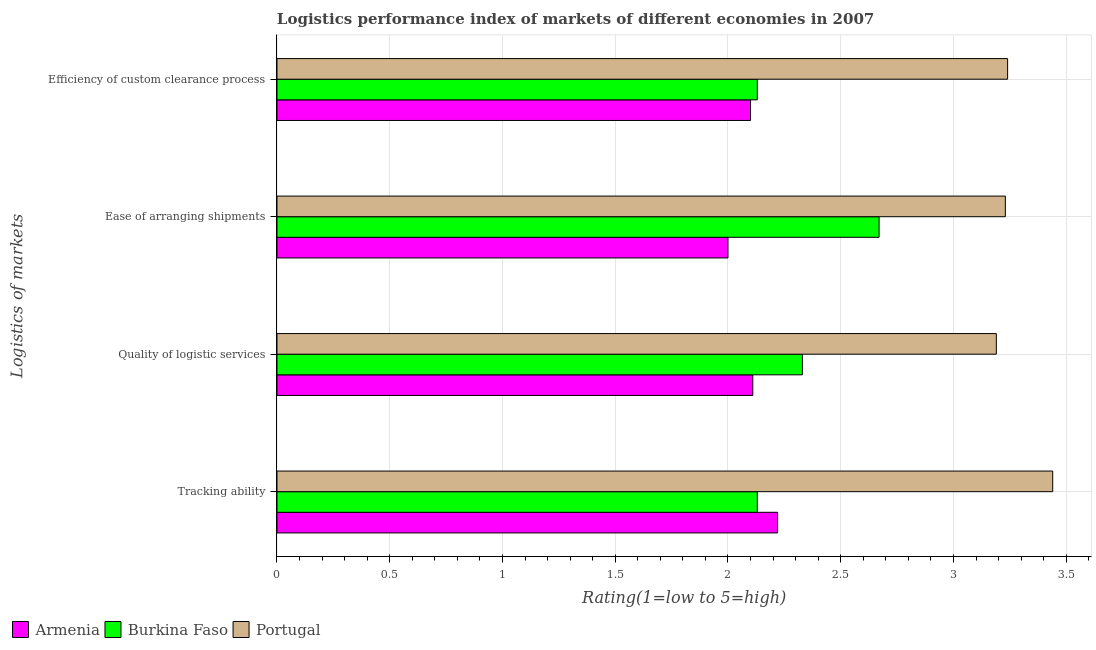Are the number of bars per tick equal to the number of legend labels?
Give a very brief answer. Yes. What is the label of the 4th group of bars from the top?
Keep it short and to the point. Tracking ability. What is the lpi rating of quality of logistic services in Burkina Faso?
Provide a succinct answer. 2.33. Across all countries, what is the maximum lpi rating of tracking ability?
Keep it short and to the point. 3.44. Across all countries, what is the minimum lpi rating of efficiency of custom clearance process?
Offer a very short reply. 2.1. In which country was the lpi rating of tracking ability minimum?
Make the answer very short. Burkina Faso. What is the difference between the lpi rating of efficiency of custom clearance process in Portugal and that in Armenia?
Make the answer very short. 1.14. What is the difference between the lpi rating of efficiency of custom clearance process in Burkina Faso and the lpi rating of tracking ability in Armenia?
Your answer should be compact. -0.09. What is the average lpi rating of efficiency of custom clearance process per country?
Keep it short and to the point. 2.49. What is the difference between the lpi rating of ease of arranging shipments and lpi rating of efficiency of custom clearance process in Armenia?
Your answer should be very brief. -0.1. In how many countries, is the lpi rating of tracking ability greater than 2.6 ?
Provide a short and direct response. 1. What is the ratio of the lpi rating of efficiency of custom clearance process in Armenia to that in Burkina Faso?
Provide a succinct answer. 0.99. Is the difference between the lpi rating of efficiency of custom clearance process in Armenia and Portugal greater than the difference between the lpi rating of quality of logistic services in Armenia and Portugal?
Give a very brief answer. No. What is the difference between the highest and the second highest lpi rating of ease of arranging shipments?
Ensure brevity in your answer.  0.56. What is the difference between the highest and the lowest lpi rating of ease of arranging shipments?
Your answer should be very brief. 1.23. Is the sum of the lpi rating of ease of arranging shipments in Portugal and Armenia greater than the maximum lpi rating of tracking ability across all countries?
Keep it short and to the point. Yes. Is it the case that in every country, the sum of the lpi rating of quality of logistic services and lpi rating of efficiency of custom clearance process is greater than the sum of lpi rating of ease of arranging shipments and lpi rating of tracking ability?
Keep it short and to the point. No. What does the 2nd bar from the bottom in Efficiency of custom clearance process represents?
Provide a short and direct response. Burkina Faso. Is it the case that in every country, the sum of the lpi rating of tracking ability and lpi rating of quality of logistic services is greater than the lpi rating of ease of arranging shipments?
Give a very brief answer. Yes. How many bars are there?
Ensure brevity in your answer.  12. How many countries are there in the graph?
Keep it short and to the point. 3. What is the difference between two consecutive major ticks on the X-axis?
Ensure brevity in your answer.  0.5. Are the values on the major ticks of X-axis written in scientific E-notation?
Ensure brevity in your answer.  No. Does the graph contain any zero values?
Give a very brief answer. No. Does the graph contain grids?
Provide a short and direct response. Yes. How many legend labels are there?
Offer a terse response. 3. What is the title of the graph?
Keep it short and to the point. Logistics performance index of markets of different economies in 2007. Does "Euro area" appear as one of the legend labels in the graph?
Your answer should be compact. No. What is the label or title of the X-axis?
Offer a terse response. Rating(1=low to 5=high). What is the label or title of the Y-axis?
Provide a short and direct response. Logistics of markets. What is the Rating(1=low to 5=high) in Armenia in Tracking ability?
Provide a short and direct response. 2.22. What is the Rating(1=low to 5=high) in Burkina Faso in Tracking ability?
Give a very brief answer. 2.13. What is the Rating(1=low to 5=high) of Portugal in Tracking ability?
Make the answer very short. 3.44. What is the Rating(1=low to 5=high) in Armenia in Quality of logistic services?
Your answer should be compact. 2.11. What is the Rating(1=low to 5=high) in Burkina Faso in Quality of logistic services?
Your answer should be very brief. 2.33. What is the Rating(1=low to 5=high) in Portugal in Quality of logistic services?
Offer a terse response. 3.19. What is the Rating(1=low to 5=high) in Burkina Faso in Ease of arranging shipments?
Your answer should be compact. 2.67. What is the Rating(1=low to 5=high) of Portugal in Ease of arranging shipments?
Provide a succinct answer. 3.23. What is the Rating(1=low to 5=high) in Armenia in Efficiency of custom clearance process?
Make the answer very short. 2.1. What is the Rating(1=low to 5=high) in Burkina Faso in Efficiency of custom clearance process?
Your answer should be compact. 2.13. What is the Rating(1=low to 5=high) of Portugal in Efficiency of custom clearance process?
Your answer should be compact. 3.24. Across all Logistics of markets, what is the maximum Rating(1=low to 5=high) in Armenia?
Make the answer very short. 2.22. Across all Logistics of markets, what is the maximum Rating(1=low to 5=high) in Burkina Faso?
Provide a succinct answer. 2.67. Across all Logistics of markets, what is the maximum Rating(1=low to 5=high) of Portugal?
Provide a succinct answer. 3.44. Across all Logistics of markets, what is the minimum Rating(1=low to 5=high) in Armenia?
Offer a terse response. 2. Across all Logistics of markets, what is the minimum Rating(1=low to 5=high) in Burkina Faso?
Your answer should be very brief. 2.13. Across all Logistics of markets, what is the minimum Rating(1=low to 5=high) of Portugal?
Make the answer very short. 3.19. What is the total Rating(1=low to 5=high) of Armenia in the graph?
Offer a very short reply. 8.43. What is the total Rating(1=low to 5=high) in Burkina Faso in the graph?
Provide a succinct answer. 9.26. What is the difference between the Rating(1=low to 5=high) in Armenia in Tracking ability and that in Quality of logistic services?
Give a very brief answer. 0.11. What is the difference between the Rating(1=low to 5=high) in Portugal in Tracking ability and that in Quality of logistic services?
Make the answer very short. 0.25. What is the difference between the Rating(1=low to 5=high) in Armenia in Tracking ability and that in Ease of arranging shipments?
Provide a succinct answer. 0.22. What is the difference between the Rating(1=low to 5=high) of Burkina Faso in Tracking ability and that in Ease of arranging shipments?
Provide a succinct answer. -0.54. What is the difference between the Rating(1=low to 5=high) of Portugal in Tracking ability and that in Ease of arranging shipments?
Your answer should be compact. 0.21. What is the difference between the Rating(1=low to 5=high) of Armenia in Tracking ability and that in Efficiency of custom clearance process?
Offer a terse response. 0.12. What is the difference between the Rating(1=low to 5=high) in Burkina Faso in Tracking ability and that in Efficiency of custom clearance process?
Your response must be concise. 0. What is the difference between the Rating(1=low to 5=high) in Armenia in Quality of logistic services and that in Ease of arranging shipments?
Your answer should be compact. 0.11. What is the difference between the Rating(1=low to 5=high) of Burkina Faso in Quality of logistic services and that in Ease of arranging shipments?
Your answer should be very brief. -0.34. What is the difference between the Rating(1=low to 5=high) of Portugal in Quality of logistic services and that in Ease of arranging shipments?
Make the answer very short. -0.04. What is the difference between the Rating(1=low to 5=high) in Armenia in Quality of logistic services and that in Efficiency of custom clearance process?
Offer a very short reply. 0.01. What is the difference between the Rating(1=low to 5=high) in Burkina Faso in Quality of logistic services and that in Efficiency of custom clearance process?
Your answer should be compact. 0.2. What is the difference between the Rating(1=low to 5=high) in Portugal in Quality of logistic services and that in Efficiency of custom clearance process?
Keep it short and to the point. -0.05. What is the difference between the Rating(1=low to 5=high) of Armenia in Ease of arranging shipments and that in Efficiency of custom clearance process?
Make the answer very short. -0.1. What is the difference between the Rating(1=low to 5=high) of Burkina Faso in Ease of arranging shipments and that in Efficiency of custom clearance process?
Offer a terse response. 0.54. What is the difference between the Rating(1=low to 5=high) in Portugal in Ease of arranging shipments and that in Efficiency of custom clearance process?
Offer a terse response. -0.01. What is the difference between the Rating(1=low to 5=high) in Armenia in Tracking ability and the Rating(1=low to 5=high) in Burkina Faso in Quality of logistic services?
Provide a short and direct response. -0.11. What is the difference between the Rating(1=low to 5=high) in Armenia in Tracking ability and the Rating(1=low to 5=high) in Portugal in Quality of logistic services?
Your answer should be compact. -0.97. What is the difference between the Rating(1=low to 5=high) in Burkina Faso in Tracking ability and the Rating(1=low to 5=high) in Portugal in Quality of logistic services?
Your answer should be very brief. -1.06. What is the difference between the Rating(1=low to 5=high) in Armenia in Tracking ability and the Rating(1=low to 5=high) in Burkina Faso in Ease of arranging shipments?
Provide a short and direct response. -0.45. What is the difference between the Rating(1=low to 5=high) of Armenia in Tracking ability and the Rating(1=low to 5=high) of Portugal in Ease of arranging shipments?
Give a very brief answer. -1.01. What is the difference between the Rating(1=low to 5=high) in Armenia in Tracking ability and the Rating(1=low to 5=high) in Burkina Faso in Efficiency of custom clearance process?
Ensure brevity in your answer.  0.09. What is the difference between the Rating(1=low to 5=high) of Armenia in Tracking ability and the Rating(1=low to 5=high) of Portugal in Efficiency of custom clearance process?
Your answer should be very brief. -1.02. What is the difference between the Rating(1=low to 5=high) in Burkina Faso in Tracking ability and the Rating(1=low to 5=high) in Portugal in Efficiency of custom clearance process?
Your answer should be compact. -1.11. What is the difference between the Rating(1=low to 5=high) of Armenia in Quality of logistic services and the Rating(1=low to 5=high) of Burkina Faso in Ease of arranging shipments?
Provide a succinct answer. -0.56. What is the difference between the Rating(1=low to 5=high) in Armenia in Quality of logistic services and the Rating(1=low to 5=high) in Portugal in Ease of arranging shipments?
Ensure brevity in your answer.  -1.12. What is the difference between the Rating(1=low to 5=high) in Armenia in Quality of logistic services and the Rating(1=low to 5=high) in Burkina Faso in Efficiency of custom clearance process?
Make the answer very short. -0.02. What is the difference between the Rating(1=low to 5=high) in Armenia in Quality of logistic services and the Rating(1=low to 5=high) in Portugal in Efficiency of custom clearance process?
Provide a short and direct response. -1.13. What is the difference between the Rating(1=low to 5=high) of Burkina Faso in Quality of logistic services and the Rating(1=low to 5=high) of Portugal in Efficiency of custom clearance process?
Provide a short and direct response. -0.91. What is the difference between the Rating(1=low to 5=high) of Armenia in Ease of arranging shipments and the Rating(1=low to 5=high) of Burkina Faso in Efficiency of custom clearance process?
Make the answer very short. -0.13. What is the difference between the Rating(1=low to 5=high) of Armenia in Ease of arranging shipments and the Rating(1=low to 5=high) of Portugal in Efficiency of custom clearance process?
Your response must be concise. -1.24. What is the difference between the Rating(1=low to 5=high) of Burkina Faso in Ease of arranging shipments and the Rating(1=low to 5=high) of Portugal in Efficiency of custom clearance process?
Provide a succinct answer. -0.57. What is the average Rating(1=low to 5=high) in Armenia per Logistics of markets?
Keep it short and to the point. 2.11. What is the average Rating(1=low to 5=high) of Burkina Faso per Logistics of markets?
Provide a succinct answer. 2.31. What is the average Rating(1=low to 5=high) in Portugal per Logistics of markets?
Ensure brevity in your answer.  3.27. What is the difference between the Rating(1=low to 5=high) of Armenia and Rating(1=low to 5=high) of Burkina Faso in Tracking ability?
Give a very brief answer. 0.09. What is the difference between the Rating(1=low to 5=high) of Armenia and Rating(1=low to 5=high) of Portugal in Tracking ability?
Give a very brief answer. -1.22. What is the difference between the Rating(1=low to 5=high) of Burkina Faso and Rating(1=low to 5=high) of Portugal in Tracking ability?
Offer a very short reply. -1.31. What is the difference between the Rating(1=low to 5=high) of Armenia and Rating(1=low to 5=high) of Burkina Faso in Quality of logistic services?
Make the answer very short. -0.22. What is the difference between the Rating(1=low to 5=high) of Armenia and Rating(1=low to 5=high) of Portugal in Quality of logistic services?
Keep it short and to the point. -1.08. What is the difference between the Rating(1=low to 5=high) in Burkina Faso and Rating(1=low to 5=high) in Portugal in Quality of logistic services?
Ensure brevity in your answer.  -0.86. What is the difference between the Rating(1=low to 5=high) of Armenia and Rating(1=low to 5=high) of Burkina Faso in Ease of arranging shipments?
Ensure brevity in your answer.  -0.67. What is the difference between the Rating(1=low to 5=high) of Armenia and Rating(1=low to 5=high) of Portugal in Ease of arranging shipments?
Offer a terse response. -1.23. What is the difference between the Rating(1=low to 5=high) in Burkina Faso and Rating(1=low to 5=high) in Portugal in Ease of arranging shipments?
Provide a succinct answer. -0.56. What is the difference between the Rating(1=low to 5=high) in Armenia and Rating(1=low to 5=high) in Burkina Faso in Efficiency of custom clearance process?
Provide a short and direct response. -0.03. What is the difference between the Rating(1=low to 5=high) in Armenia and Rating(1=low to 5=high) in Portugal in Efficiency of custom clearance process?
Offer a terse response. -1.14. What is the difference between the Rating(1=low to 5=high) in Burkina Faso and Rating(1=low to 5=high) in Portugal in Efficiency of custom clearance process?
Offer a terse response. -1.11. What is the ratio of the Rating(1=low to 5=high) of Armenia in Tracking ability to that in Quality of logistic services?
Give a very brief answer. 1.05. What is the ratio of the Rating(1=low to 5=high) in Burkina Faso in Tracking ability to that in Quality of logistic services?
Give a very brief answer. 0.91. What is the ratio of the Rating(1=low to 5=high) of Portugal in Tracking ability to that in Quality of logistic services?
Keep it short and to the point. 1.08. What is the ratio of the Rating(1=low to 5=high) of Armenia in Tracking ability to that in Ease of arranging shipments?
Your response must be concise. 1.11. What is the ratio of the Rating(1=low to 5=high) in Burkina Faso in Tracking ability to that in Ease of arranging shipments?
Ensure brevity in your answer.  0.8. What is the ratio of the Rating(1=low to 5=high) of Portugal in Tracking ability to that in Ease of arranging shipments?
Your response must be concise. 1.06. What is the ratio of the Rating(1=low to 5=high) in Armenia in Tracking ability to that in Efficiency of custom clearance process?
Offer a terse response. 1.06. What is the ratio of the Rating(1=low to 5=high) in Burkina Faso in Tracking ability to that in Efficiency of custom clearance process?
Offer a terse response. 1. What is the ratio of the Rating(1=low to 5=high) in Portugal in Tracking ability to that in Efficiency of custom clearance process?
Ensure brevity in your answer.  1.06. What is the ratio of the Rating(1=low to 5=high) in Armenia in Quality of logistic services to that in Ease of arranging shipments?
Make the answer very short. 1.05. What is the ratio of the Rating(1=low to 5=high) in Burkina Faso in Quality of logistic services to that in Ease of arranging shipments?
Offer a very short reply. 0.87. What is the ratio of the Rating(1=low to 5=high) of Portugal in Quality of logistic services to that in Ease of arranging shipments?
Your response must be concise. 0.99. What is the ratio of the Rating(1=low to 5=high) of Armenia in Quality of logistic services to that in Efficiency of custom clearance process?
Your answer should be compact. 1. What is the ratio of the Rating(1=low to 5=high) in Burkina Faso in Quality of logistic services to that in Efficiency of custom clearance process?
Your response must be concise. 1.09. What is the ratio of the Rating(1=low to 5=high) in Portugal in Quality of logistic services to that in Efficiency of custom clearance process?
Give a very brief answer. 0.98. What is the ratio of the Rating(1=low to 5=high) in Burkina Faso in Ease of arranging shipments to that in Efficiency of custom clearance process?
Offer a very short reply. 1.25. What is the ratio of the Rating(1=low to 5=high) of Portugal in Ease of arranging shipments to that in Efficiency of custom clearance process?
Ensure brevity in your answer.  1. What is the difference between the highest and the second highest Rating(1=low to 5=high) of Armenia?
Offer a very short reply. 0.11. What is the difference between the highest and the second highest Rating(1=low to 5=high) of Burkina Faso?
Your answer should be very brief. 0.34. What is the difference between the highest and the second highest Rating(1=low to 5=high) in Portugal?
Your answer should be very brief. 0.2. What is the difference between the highest and the lowest Rating(1=low to 5=high) of Armenia?
Make the answer very short. 0.22. What is the difference between the highest and the lowest Rating(1=low to 5=high) of Burkina Faso?
Give a very brief answer. 0.54. 